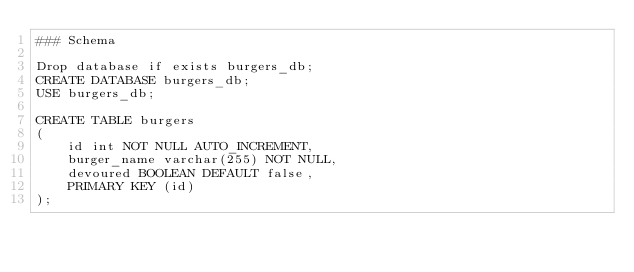<code> <loc_0><loc_0><loc_500><loc_500><_SQL_>### Schema

Drop database if exists burgers_db;
CREATE DATABASE burgers_db;
USE burgers_db;

CREATE TABLE burgers
(
	id int NOT NULL AUTO_INCREMENT,
	burger_name varchar(255) NOT NULL,
	devoured BOOLEAN DEFAULT false,
	PRIMARY KEY (id)
);</code> 